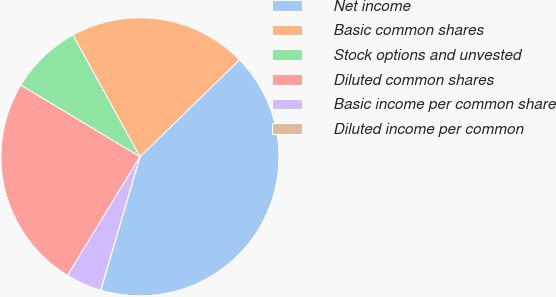<chart> <loc_0><loc_0><loc_500><loc_500><pie_chart><fcel>Net income<fcel>Basic common shares<fcel>Stock options and unvested<fcel>Diluted common shares<fcel>Basic income per common share<fcel>Diluted income per common<nl><fcel>41.84%<fcel>20.71%<fcel>8.37%<fcel>24.89%<fcel>4.18%<fcel>0.0%<nl></chart> 